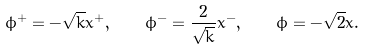Convert formula to latex. <formula><loc_0><loc_0><loc_500><loc_500>\phi ^ { + } = - \sqrt { k } x ^ { + } , \quad \phi ^ { - } = \frac { 2 } { \sqrt { k } } x ^ { - } , \quad \phi = - \sqrt { 2 } x .</formula> 